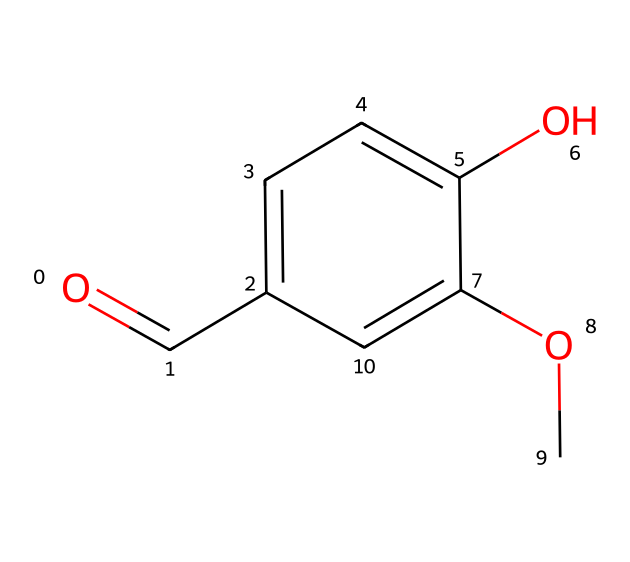What is the molecular formula of vanillin? To find the molecular formula, we look at the SMILES representation to count the number of each type of atom. In the SMILES, we can identify 8 carbons (C), 8 hydrogens (H), and 3 oxygens (O). Thus, the molecular formula is C8H8O3.
Answer: C8H8O3 How many hydroxyl (–OH) groups are present in vanillin? By analyzing the structure in the SMILES, we see that there is one hydroxyl group attached to the benzene ring. This is indicated by the "O" attached to a carbon with a hydrogen, revealing its alcohol functionality.
Answer: one What type of functional groups are present in vanillin? In the SMILES, we recognize two main functional groups: a hydroxyl group (–OH) and a carbonyl group (–C=O). The carbonyl is part of the aldehyde formation in vanillin. This combination of groups influences its flavor profile.
Answer: hydroxyl and carbonyl Which part of the chemical structure provides vanillin its sweet flavor? The aldehyde carbonyl (–C=O) group is responsible for sweet and aromatic properties as found in vanilla. The structure, which includes this carbonyl, plays a vital role in the flavor profile of vanillin, enhancing its sweet aroma in confectionery.
Answer: carbonyl group How does the presence of the methoxy (–OCH3) group affect vanillin's properties? The methoxy group (–OCH3) is an electron-donating group, which enhances the aromatic properties of vanillin by increasing the electron density on the aromatic ring. This leads to a sweeter and more fragrant profile in flavorings.
Answer: enhances sweetness and aroma What historical significance does vanillin have in confectionery? Vanillin has been used since the 18th century as an important flavoring agent in confectionery, elevating desserts and sweets with its rich vanilla flavor. Its use has historical relevance due to its prevalence in desserts of that time.
Answer: flavoring agent in confectionery Is vanillin a natural or synthetic additive? Vanillin can be derived from natural sources like vanilla beans, but it is also commonly synthesized chemically today, making it a versatile additive in various culinary applications.
Answer: both natural and synthetic 